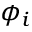<formula> <loc_0><loc_0><loc_500><loc_500>\phi _ { i }</formula> 